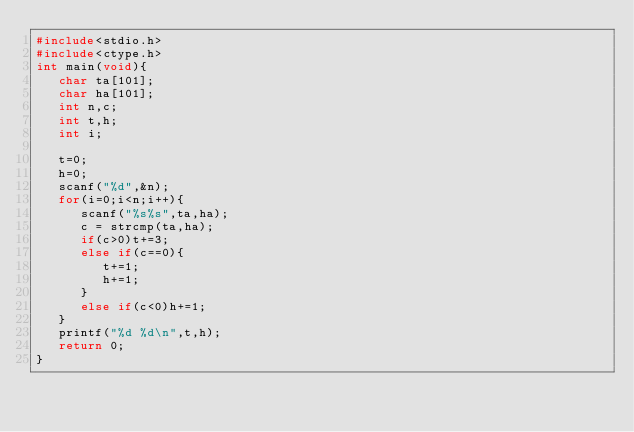Convert code to text. <code><loc_0><loc_0><loc_500><loc_500><_C_>#include<stdio.h>
#include<ctype.h>
int main(void){
   char ta[101];
   char ha[101];
   int n,c;
   int t,h;
   int i;

   t=0;
   h=0;
   scanf("%d",&n);
   for(i=0;i<n;i++){
      scanf("%s%s",ta,ha);
      c = strcmp(ta,ha);
      if(c>0)t+=3;
      else if(c==0){
         t+=1;
         h+=1;
      }
      else if(c<0)h+=1;
   }
   printf("%d %d\n",t,h);
   return 0;
}</code> 